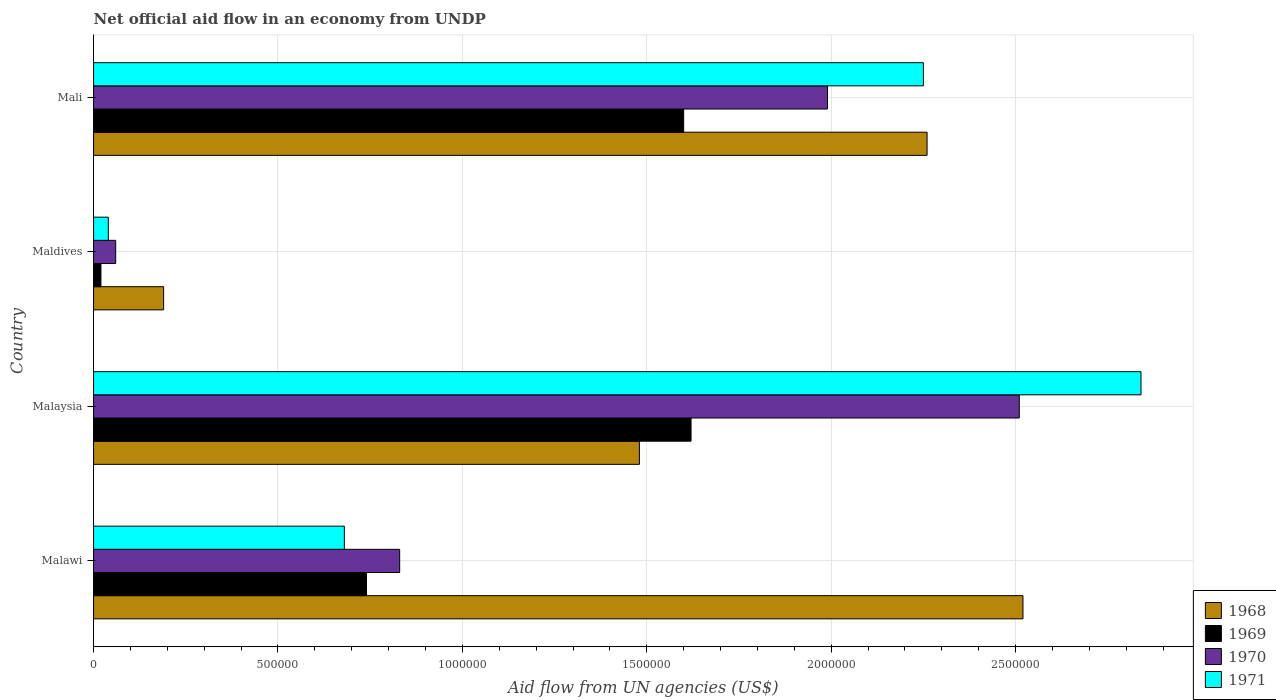How many different coloured bars are there?
Provide a short and direct response. 4. How many groups of bars are there?
Keep it short and to the point. 4. Are the number of bars on each tick of the Y-axis equal?
Your answer should be very brief. Yes. What is the label of the 4th group of bars from the top?
Provide a succinct answer. Malawi. What is the net official aid flow in 1968 in Malaysia?
Your answer should be very brief. 1.48e+06. Across all countries, what is the maximum net official aid flow in 1969?
Your response must be concise. 1.62e+06. In which country was the net official aid flow in 1971 maximum?
Provide a short and direct response. Malaysia. In which country was the net official aid flow in 1968 minimum?
Your response must be concise. Maldives. What is the total net official aid flow in 1968 in the graph?
Provide a succinct answer. 6.45e+06. What is the difference between the net official aid flow in 1971 in Malawi and that in Maldives?
Give a very brief answer. 6.40e+05. What is the difference between the net official aid flow in 1969 in Maldives and the net official aid flow in 1971 in Malawi?
Your answer should be compact. -6.60e+05. What is the average net official aid flow in 1969 per country?
Keep it short and to the point. 9.95e+05. What is the difference between the net official aid flow in 1970 and net official aid flow in 1969 in Mali?
Your response must be concise. 3.90e+05. What is the ratio of the net official aid flow in 1969 in Malaysia to that in Maldives?
Your response must be concise. 81. Is the net official aid flow in 1970 in Malaysia less than that in Mali?
Provide a short and direct response. No. Is the difference between the net official aid flow in 1970 in Malawi and Maldives greater than the difference between the net official aid flow in 1969 in Malawi and Maldives?
Your answer should be compact. Yes. What is the difference between the highest and the second highest net official aid flow in 1971?
Your response must be concise. 5.90e+05. What is the difference between the highest and the lowest net official aid flow in 1968?
Ensure brevity in your answer.  2.33e+06. In how many countries, is the net official aid flow in 1971 greater than the average net official aid flow in 1971 taken over all countries?
Provide a succinct answer. 2. Is the sum of the net official aid flow in 1970 in Malawi and Maldives greater than the maximum net official aid flow in 1969 across all countries?
Your answer should be compact. No. What does the 4th bar from the top in Malawi represents?
Provide a succinct answer. 1968. What does the 4th bar from the bottom in Mali represents?
Provide a short and direct response. 1971. Is it the case that in every country, the sum of the net official aid flow in 1969 and net official aid flow in 1971 is greater than the net official aid flow in 1970?
Give a very brief answer. No. Are all the bars in the graph horizontal?
Offer a terse response. Yes. Where does the legend appear in the graph?
Provide a short and direct response. Bottom right. How many legend labels are there?
Your answer should be very brief. 4. What is the title of the graph?
Give a very brief answer. Net official aid flow in an economy from UNDP. Does "1986" appear as one of the legend labels in the graph?
Provide a short and direct response. No. What is the label or title of the X-axis?
Your answer should be compact. Aid flow from UN agencies (US$). What is the label or title of the Y-axis?
Your answer should be compact. Country. What is the Aid flow from UN agencies (US$) in 1968 in Malawi?
Provide a short and direct response. 2.52e+06. What is the Aid flow from UN agencies (US$) in 1969 in Malawi?
Keep it short and to the point. 7.40e+05. What is the Aid flow from UN agencies (US$) in 1970 in Malawi?
Give a very brief answer. 8.30e+05. What is the Aid flow from UN agencies (US$) of 1971 in Malawi?
Provide a short and direct response. 6.80e+05. What is the Aid flow from UN agencies (US$) of 1968 in Malaysia?
Ensure brevity in your answer.  1.48e+06. What is the Aid flow from UN agencies (US$) in 1969 in Malaysia?
Make the answer very short. 1.62e+06. What is the Aid flow from UN agencies (US$) of 1970 in Malaysia?
Keep it short and to the point. 2.51e+06. What is the Aid flow from UN agencies (US$) of 1971 in Malaysia?
Keep it short and to the point. 2.84e+06. What is the Aid flow from UN agencies (US$) of 1968 in Maldives?
Give a very brief answer. 1.90e+05. What is the Aid flow from UN agencies (US$) of 1969 in Maldives?
Your answer should be very brief. 2.00e+04. What is the Aid flow from UN agencies (US$) of 1971 in Maldives?
Your answer should be compact. 4.00e+04. What is the Aid flow from UN agencies (US$) in 1968 in Mali?
Offer a very short reply. 2.26e+06. What is the Aid flow from UN agencies (US$) of 1969 in Mali?
Your answer should be very brief. 1.60e+06. What is the Aid flow from UN agencies (US$) in 1970 in Mali?
Ensure brevity in your answer.  1.99e+06. What is the Aid flow from UN agencies (US$) of 1971 in Mali?
Ensure brevity in your answer.  2.25e+06. Across all countries, what is the maximum Aid flow from UN agencies (US$) of 1968?
Make the answer very short. 2.52e+06. Across all countries, what is the maximum Aid flow from UN agencies (US$) in 1969?
Your answer should be very brief. 1.62e+06. Across all countries, what is the maximum Aid flow from UN agencies (US$) in 1970?
Make the answer very short. 2.51e+06. Across all countries, what is the maximum Aid flow from UN agencies (US$) in 1971?
Offer a very short reply. 2.84e+06. Across all countries, what is the minimum Aid flow from UN agencies (US$) in 1968?
Your answer should be compact. 1.90e+05. Across all countries, what is the minimum Aid flow from UN agencies (US$) in 1971?
Your answer should be very brief. 4.00e+04. What is the total Aid flow from UN agencies (US$) of 1968 in the graph?
Provide a short and direct response. 6.45e+06. What is the total Aid flow from UN agencies (US$) in 1969 in the graph?
Provide a short and direct response. 3.98e+06. What is the total Aid flow from UN agencies (US$) in 1970 in the graph?
Make the answer very short. 5.39e+06. What is the total Aid flow from UN agencies (US$) in 1971 in the graph?
Make the answer very short. 5.81e+06. What is the difference between the Aid flow from UN agencies (US$) in 1968 in Malawi and that in Malaysia?
Your response must be concise. 1.04e+06. What is the difference between the Aid flow from UN agencies (US$) of 1969 in Malawi and that in Malaysia?
Your answer should be very brief. -8.80e+05. What is the difference between the Aid flow from UN agencies (US$) in 1970 in Malawi and that in Malaysia?
Provide a short and direct response. -1.68e+06. What is the difference between the Aid flow from UN agencies (US$) of 1971 in Malawi and that in Malaysia?
Provide a succinct answer. -2.16e+06. What is the difference between the Aid flow from UN agencies (US$) of 1968 in Malawi and that in Maldives?
Make the answer very short. 2.33e+06. What is the difference between the Aid flow from UN agencies (US$) in 1969 in Malawi and that in Maldives?
Make the answer very short. 7.20e+05. What is the difference between the Aid flow from UN agencies (US$) of 1970 in Malawi and that in Maldives?
Give a very brief answer. 7.70e+05. What is the difference between the Aid flow from UN agencies (US$) of 1971 in Malawi and that in Maldives?
Provide a succinct answer. 6.40e+05. What is the difference between the Aid flow from UN agencies (US$) in 1968 in Malawi and that in Mali?
Your answer should be compact. 2.60e+05. What is the difference between the Aid flow from UN agencies (US$) in 1969 in Malawi and that in Mali?
Offer a very short reply. -8.60e+05. What is the difference between the Aid flow from UN agencies (US$) of 1970 in Malawi and that in Mali?
Provide a succinct answer. -1.16e+06. What is the difference between the Aid flow from UN agencies (US$) in 1971 in Malawi and that in Mali?
Keep it short and to the point. -1.57e+06. What is the difference between the Aid flow from UN agencies (US$) of 1968 in Malaysia and that in Maldives?
Give a very brief answer. 1.29e+06. What is the difference between the Aid flow from UN agencies (US$) of 1969 in Malaysia and that in Maldives?
Provide a short and direct response. 1.60e+06. What is the difference between the Aid flow from UN agencies (US$) in 1970 in Malaysia and that in Maldives?
Your answer should be compact. 2.45e+06. What is the difference between the Aid flow from UN agencies (US$) in 1971 in Malaysia and that in Maldives?
Give a very brief answer. 2.80e+06. What is the difference between the Aid flow from UN agencies (US$) of 1968 in Malaysia and that in Mali?
Provide a succinct answer. -7.80e+05. What is the difference between the Aid flow from UN agencies (US$) in 1970 in Malaysia and that in Mali?
Offer a very short reply. 5.20e+05. What is the difference between the Aid flow from UN agencies (US$) of 1971 in Malaysia and that in Mali?
Your answer should be compact. 5.90e+05. What is the difference between the Aid flow from UN agencies (US$) of 1968 in Maldives and that in Mali?
Offer a terse response. -2.07e+06. What is the difference between the Aid flow from UN agencies (US$) in 1969 in Maldives and that in Mali?
Ensure brevity in your answer.  -1.58e+06. What is the difference between the Aid flow from UN agencies (US$) in 1970 in Maldives and that in Mali?
Keep it short and to the point. -1.93e+06. What is the difference between the Aid flow from UN agencies (US$) in 1971 in Maldives and that in Mali?
Your response must be concise. -2.21e+06. What is the difference between the Aid flow from UN agencies (US$) in 1968 in Malawi and the Aid flow from UN agencies (US$) in 1969 in Malaysia?
Your answer should be very brief. 9.00e+05. What is the difference between the Aid flow from UN agencies (US$) in 1968 in Malawi and the Aid flow from UN agencies (US$) in 1971 in Malaysia?
Offer a very short reply. -3.20e+05. What is the difference between the Aid flow from UN agencies (US$) in 1969 in Malawi and the Aid flow from UN agencies (US$) in 1970 in Malaysia?
Make the answer very short. -1.77e+06. What is the difference between the Aid flow from UN agencies (US$) of 1969 in Malawi and the Aid flow from UN agencies (US$) of 1971 in Malaysia?
Provide a succinct answer. -2.10e+06. What is the difference between the Aid flow from UN agencies (US$) of 1970 in Malawi and the Aid flow from UN agencies (US$) of 1971 in Malaysia?
Your answer should be very brief. -2.01e+06. What is the difference between the Aid flow from UN agencies (US$) in 1968 in Malawi and the Aid flow from UN agencies (US$) in 1969 in Maldives?
Ensure brevity in your answer.  2.50e+06. What is the difference between the Aid flow from UN agencies (US$) of 1968 in Malawi and the Aid flow from UN agencies (US$) of 1970 in Maldives?
Your answer should be compact. 2.46e+06. What is the difference between the Aid flow from UN agencies (US$) of 1968 in Malawi and the Aid flow from UN agencies (US$) of 1971 in Maldives?
Offer a terse response. 2.48e+06. What is the difference between the Aid flow from UN agencies (US$) of 1969 in Malawi and the Aid flow from UN agencies (US$) of 1970 in Maldives?
Offer a very short reply. 6.80e+05. What is the difference between the Aid flow from UN agencies (US$) in 1969 in Malawi and the Aid flow from UN agencies (US$) in 1971 in Maldives?
Offer a terse response. 7.00e+05. What is the difference between the Aid flow from UN agencies (US$) in 1970 in Malawi and the Aid flow from UN agencies (US$) in 1971 in Maldives?
Keep it short and to the point. 7.90e+05. What is the difference between the Aid flow from UN agencies (US$) in 1968 in Malawi and the Aid flow from UN agencies (US$) in 1969 in Mali?
Provide a short and direct response. 9.20e+05. What is the difference between the Aid flow from UN agencies (US$) of 1968 in Malawi and the Aid flow from UN agencies (US$) of 1970 in Mali?
Keep it short and to the point. 5.30e+05. What is the difference between the Aid flow from UN agencies (US$) in 1968 in Malawi and the Aid flow from UN agencies (US$) in 1971 in Mali?
Ensure brevity in your answer.  2.70e+05. What is the difference between the Aid flow from UN agencies (US$) in 1969 in Malawi and the Aid flow from UN agencies (US$) in 1970 in Mali?
Give a very brief answer. -1.25e+06. What is the difference between the Aid flow from UN agencies (US$) in 1969 in Malawi and the Aid flow from UN agencies (US$) in 1971 in Mali?
Ensure brevity in your answer.  -1.51e+06. What is the difference between the Aid flow from UN agencies (US$) in 1970 in Malawi and the Aid flow from UN agencies (US$) in 1971 in Mali?
Your response must be concise. -1.42e+06. What is the difference between the Aid flow from UN agencies (US$) in 1968 in Malaysia and the Aid flow from UN agencies (US$) in 1969 in Maldives?
Your answer should be compact. 1.46e+06. What is the difference between the Aid flow from UN agencies (US$) in 1968 in Malaysia and the Aid flow from UN agencies (US$) in 1970 in Maldives?
Offer a terse response. 1.42e+06. What is the difference between the Aid flow from UN agencies (US$) in 1968 in Malaysia and the Aid flow from UN agencies (US$) in 1971 in Maldives?
Offer a terse response. 1.44e+06. What is the difference between the Aid flow from UN agencies (US$) in 1969 in Malaysia and the Aid flow from UN agencies (US$) in 1970 in Maldives?
Give a very brief answer. 1.56e+06. What is the difference between the Aid flow from UN agencies (US$) of 1969 in Malaysia and the Aid flow from UN agencies (US$) of 1971 in Maldives?
Your answer should be very brief. 1.58e+06. What is the difference between the Aid flow from UN agencies (US$) of 1970 in Malaysia and the Aid flow from UN agencies (US$) of 1971 in Maldives?
Provide a short and direct response. 2.47e+06. What is the difference between the Aid flow from UN agencies (US$) of 1968 in Malaysia and the Aid flow from UN agencies (US$) of 1969 in Mali?
Make the answer very short. -1.20e+05. What is the difference between the Aid flow from UN agencies (US$) in 1968 in Malaysia and the Aid flow from UN agencies (US$) in 1970 in Mali?
Give a very brief answer. -5.10e+05. What is the difference between the Aid flow from UN agencies (US$) in 1968 in Malaysia and the Aid flow from UN agencies (US$) in 1971 in Mali?
Offer a very short reply. -7.70e+05. What is the difference between the Aid flow from UN agencies (US$) of 1969 in Malaysia and the Aid flow from UN agencies (US$) of 1970 in Mali?
Offer a very short reply. -3.70e+05. What is the difference between the Aid flow from UN agencies (US$) in 1969 in Malaysia and the Aid flow from UN agencies (US$) in 1971 in Mali?
Ensure brevity in your answer.  -6.30e+05. What is the difference between the Aid flow from UN agencies (US$) of 1968 in Maldives and the Aid flow from UN agencies (US$) of 1969 in Mali?
Your response must be concise. -1.41e+06. What is the difference between the Aid flow from UN agencies (US$) in 1968 in Maldives and the Aid flow from UN agencies (US$) in 1970 in Mali?
Offer a very short reply. -1.80e+06. What is the difference between the Aid flow from UN agencies (US$) in 1968 in Maldives and the Aid flow from UN agencies (US$) in 1971 in Mali?
Give a very brief answer. -2.06e+06. What is the difference between the Aid flow from UN agencies (US$) of 1969 in Maldives and the Aid flow from UN agencies (US$) of 1970 in Mali?
Provide a succinct answer. -1.97e+06. What is the difference between the Aid flow from UN agencies (US$) in 1969 in Maldives and the Aid flow from UN agencies (US$) in 1971 in Mali?
Ensure brevity in your answer.  -2.23e+06. What is the difference between the Aid flow from UN agencies (US$) in 1970 in Maldives and the Aid flow from UN agencies (US$) in 1971 in Mali?
Your answer should be compact. -2.19e+06. What is the average Aid flow from UN agencies (US$) in 1968 per country?
Offer a terse response. 1.61e+06. What is the average Aid flow from UN agencies (US$) of 1969 per country?
Your answer should be very brief. 9.95e+05. What is the average Aid flow from UN agencies (US$) in 1970 per country?
Give a very brief answer. 1.35e+06. What is the average Aid flow from UN agencies (US$) of 1971 per country?
Your answer should be compact. 1.45e+06. What is the difference between the Aid flow from UN agencies (US$) of 1968 and Aid flow from UN agencies (US$) of 1969 in Malawi?
Offer a terse response. 1.78e+06. What is the difference between the Aid flow from UN agencies (US$) in 1968 and Aid flow from UN agencies (US$) in 1970 in Malawi?
Provide a short and direct response. 1.69e+06. What is the difference between the Aid flow from UN agencies (US$) of 1968 and Aid flow from UN agencies (US$) of 1971 in Malawi?
Make the answer very short. 1.84e+06. What is the difference between the Aid flow from UN agencies (US$) of 1969 and Aid flow from UN agencies (US$) of 1970 in Malawi?
Your answer should be very brief. -9.00e+04. What is the difference between the Aid flow from UN agencies (US$) in 1969 and Aid flow from UN agencies (US$) in 1971 in Malawi?
Make the answer very short. 6.00e+04. What is the difference between the Aid flow from UN agencies (US$) in 1968 and Aid flow from UN agencies (US$) in 1969 in Malaysia?
Ensure brevity in your answer.  -1.40e+05. What is the difference between the Aid flow from UN agencies (US$) in 1968 and Aid flow from UN agencies (US$) in 1970 in Malaysia?
Provide a short and direct response. -1.03e+06. What is the difference between the Aid flow from UN agencies (US$) in 1968 and Aid flow from UN agencies (US$) in 1971 in Malaysia?
Keep it short and to the point. -1.36e+06. What is the difference between the Aid flow from UN agencies (US$) in 1969 and Aid flow from UN agencies (US$) in 1970 in Malaysia?
Your answer should be compact. -8.90e+05. What is the difference between the Aid flow from UN agencies (US$) of 1969 and Aid flow from UN agencies (US$) of 1971 in Malaysia?
Provide a succinct answer. -1.22e+06. What is the difference between the Aid flow from UN agencies (US$) of 1970 and Aid flow from UN agencies (US$) of 1971 in Malaysia?
Keep it short and to the point. -3.30e+05. What is the difference between the Aid flow from UN agencies (US$) of 1968 and Aid flow from UN agencies (US$) of 1969 in Maldives?
Provide a short and direct response. 1.70e+05. What is the difference between the Aid flow from UN agencies (US$) in 1970 and Aid flow from UN agencies (US$) in 1971 in Maldives?
Offer a terse response. 2.00e+04. What is the difference between the Aid flow from UN agencies (US$) in 1968 and Aid flow from UN agencies (US$) in 1970 in Mali?
Your answer should be very brief. 2.70e+05. What is the difference between the Aid flow from UN agencies (US$) of 1968 and Aid flow from UN agencies (US$) of 1971 in Mali?
Give a very brief answer. 10000. What is the difference between the Aid flow from UN agencies (US$) of 1969 and Aid flow from UN agencies (US$) of 1970 in Mali?
Provide a short and direct response. -3.90e+05. What is the difference between the Aid flow from UN agencies (US$) of 1969 and Aid flow from UN agencies (US$) of 1971 in Mali?
Your answer should be compact. -6.50e+05. What is the difference between the Aid flow from UN agencies (US$) of 1970 and Aid flow from UN agencies (US$) of 1971 in Mali?
Your answer should be very brief. -2.60e+05. What is the ratio of the Aid flow from UN agencies (US$) in 1968 in Malawi to that in Malaysia?
Provide a succinct answer. 1.7. What is the ratio of the Aid flow from UN agencies (US$) of 1969 in Malawi to that in Malaysia?
Offer a very short reply. 0.46. What is the ratio of the Aid flow from UN agencies (US$) of 1970 in Malawi to that in Malaysia?
Your answer should be compact. 0.33. What is the ratio of the Aid flow from UN agencies (US$) in 1971 in Malawi to that in Malaysia?
Your answer should be compact. 0.24. What is the ratio of the Aid flow from UN agencies (US$) in 1968 in Malawi to that in Maldives?
Make the answer very short. 13.26. What is the ratio of the Aid flow from UN agencies (US$) of 1970 in Malawi to that in Maldives?
Make the answer very short. 13.83. What is the ratio of the Aid flow from UN agencies (US$) of 1971 in Malawi to that in Maldives?
Provide a succinct answer. 17. What is the ratio of the Aid flow from UN agencies (US$) of 1968 in Malawi to that in Mali?
Provide a succinct answer. 1.11. What is the ratio of the Aid flow from UN agencies (US$) in 1969 in Malawi to that in Mali?
Offer a terse response. 0.46. What is the ratio of the Aid flow from UN agencies (US$) of 1970 in Malawi to that in Mali?
Offer a very short reply. 0.42. What is the ratio of the Aid flow from UN agencies (US$) of 1971 in Malawi to that in Mali?
Your response must be concise. 0.3. What is the ratio of the Aid flow from UN agencies (US$) of 1968 in Malaysia to that in Maldives?
Keep it short and to the point. 7.79. What is the ratio of the Aid flow from UN agencies (US$) of 1970 in Malaysia to that in Maldives?
Your answer should be compact. 41.83. What is the ratio of the Aid flow from UN agencies (US$) in 1971 in Malaysia to that in Maldives?
Your response must be concise. 71. What is the ratio of the Aid flow from UN agencies (US$) in 1968 in Malaysia to that in Mali?
Your answer should be compact. 0.65. What is the ratio of the Aid flow from UN agencies (US$) of 1969 in Malaysia to that in Mali?
Give a very brief answer. 1.01. What is the ratio of the Aid flow from UN agencies (US$) of 1970 in Malaysia to that in Mali?
Make the answer very short. 1.26. What is the ratio of the Aid flow from UN agencies (US$) in 1971 in Malaysia to that in Mali?
Your response must be concise. 1.26. What is the ratio of the Aid flow from UN agencies (US$) of 1968 in Maldives to that in Mali?
Make the answer very short. 0.08. What is the ratio of the Aid flow from UN agencies (US$) in 1969 in Maldives to that in Mali?
Offer a very short reply. 0.01. What is the ratio of the Aid flow from UN agencies (US$) of 1970 in Maldives to that in Mali?
Your answer should be compact. 0.03. What is the ratio of the Aid flow from UN agencies (US$) of 1971 in Maldives to that in Mali?
Provide a short and direct response. 0.02. What is the difference between the highest and the second highest Aid flow from UN agencies (US$) in 1968?
Give a very brief answer. 2.60e+05. What is the difference between the highest and the second highest Aid flow from UN agencies (US$) in 1970?
Provide a short and direct response. 5.20e+05. What is the difference between the highest and the second highest Aid flow from UN agencies (US$) in 1971?
Your response must be concise. 5.90e+05. What is the difference between the highest and the lowest Aid flow from UN agencies (US$) in 1968?
Keep it short and to the point. 2.33e+06. What is the difference between the highest and the lowest Aid flow from UN agencies (US$) of 1969?
Keep it short and to the point. 1.60e+06. What is the difference between the highest and the lowest Aid flow from UN agencies (US$) in 1970?
Make the answer very short. 2.45e+06. What is the difference between the highest and the lowest Aid flow from UN agencies (US$) in 1971?
Your answer should be very brief. 2.80e+06. 